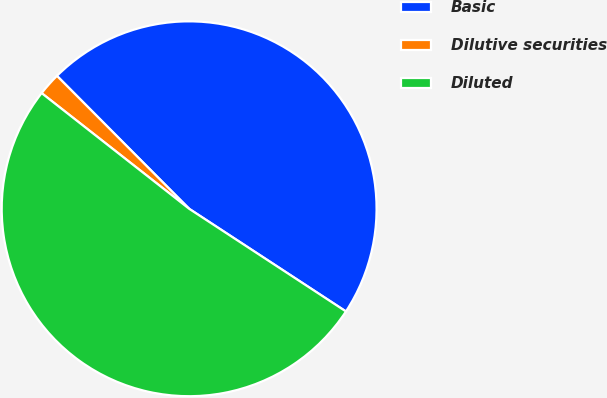Convert chart to OTSL. <chart><loc_0><loc_0><loc_500><loc_500><pie_chart><fcel>Basic<fcel>Dilutive securities<fcel>Diluted<nl><fcel>46.68%<fcel>1.96%<fcel>51.35%<nl></chart> 